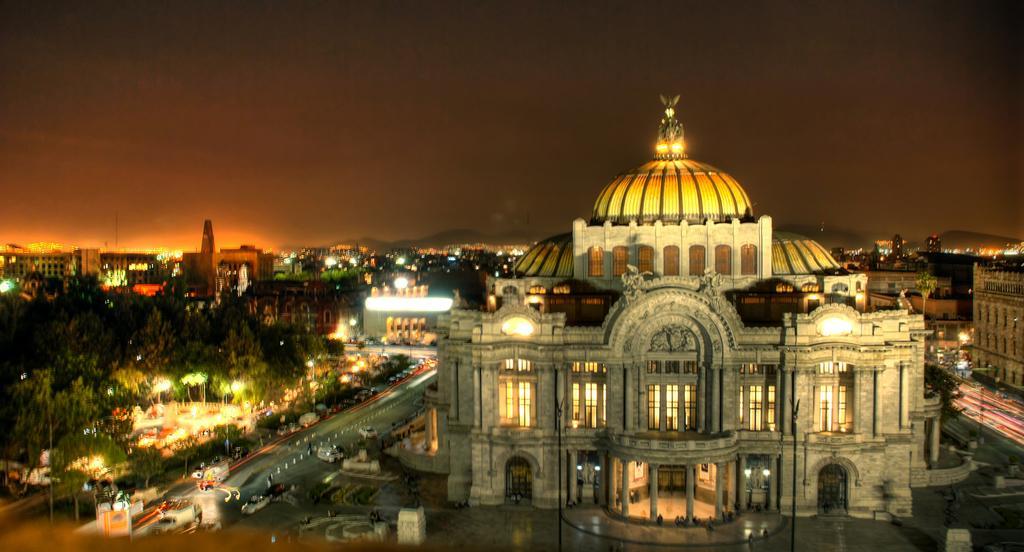How would you summarize this image in a sentence or two? In the picture we can see a palace and some lights to it and beside the palace we can see the road and vehicles on it and beside it, we can see many trees and in the background, we can see houses, buildings and lights to it and behind it we can see a sky. 